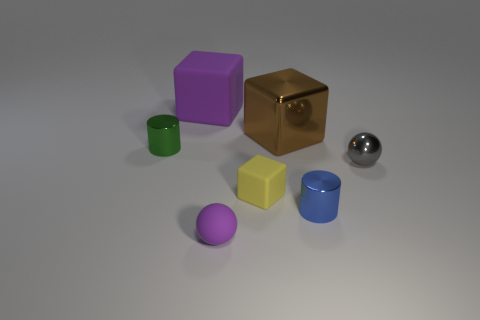Is the small thing that is behind the small gray shiny thing made of the same material as the cylinder that is on the right side of the big brown cube?
Offer a terse response. Yes. What color is the other object that is the same shape as the gray metal object?
Offer a very short reply. Purple. There is a purple object that is in front of the metallic cylinder that is in front of the gray shiny sphere; what is it made of?
Offer a very short reply. Rubber. Is the shape of the rubber object that is in front of the blue object the same as the metallic object that is left of the small yellow object?
Your answer should be compact. No. There is a cube that is on the right side of the purple cube and behind the tiny yellow object; what is its size?
Offer a very short reply. Large. What number of other things are the same color as the big metallic cube?
Keep it short and to the point. 0. Do the large thing in front of the large purple thing and the yellow thing have the same material?
Your answer should be very brief. No. Are there fewer tiny yellow blocks behind the big rubber block than tiny green cylinders on the left side of the metal block?
Keep it short and to the point. Yes. What material is the large cube that is the same color as the rubber ball?
Offer a very short reply. Rubber. There is a small object that is on the left side of the purple matte thing in front of the tiny gray object; how many small rubber cubes are in front of it?
Provide a succinct answer. 1. 